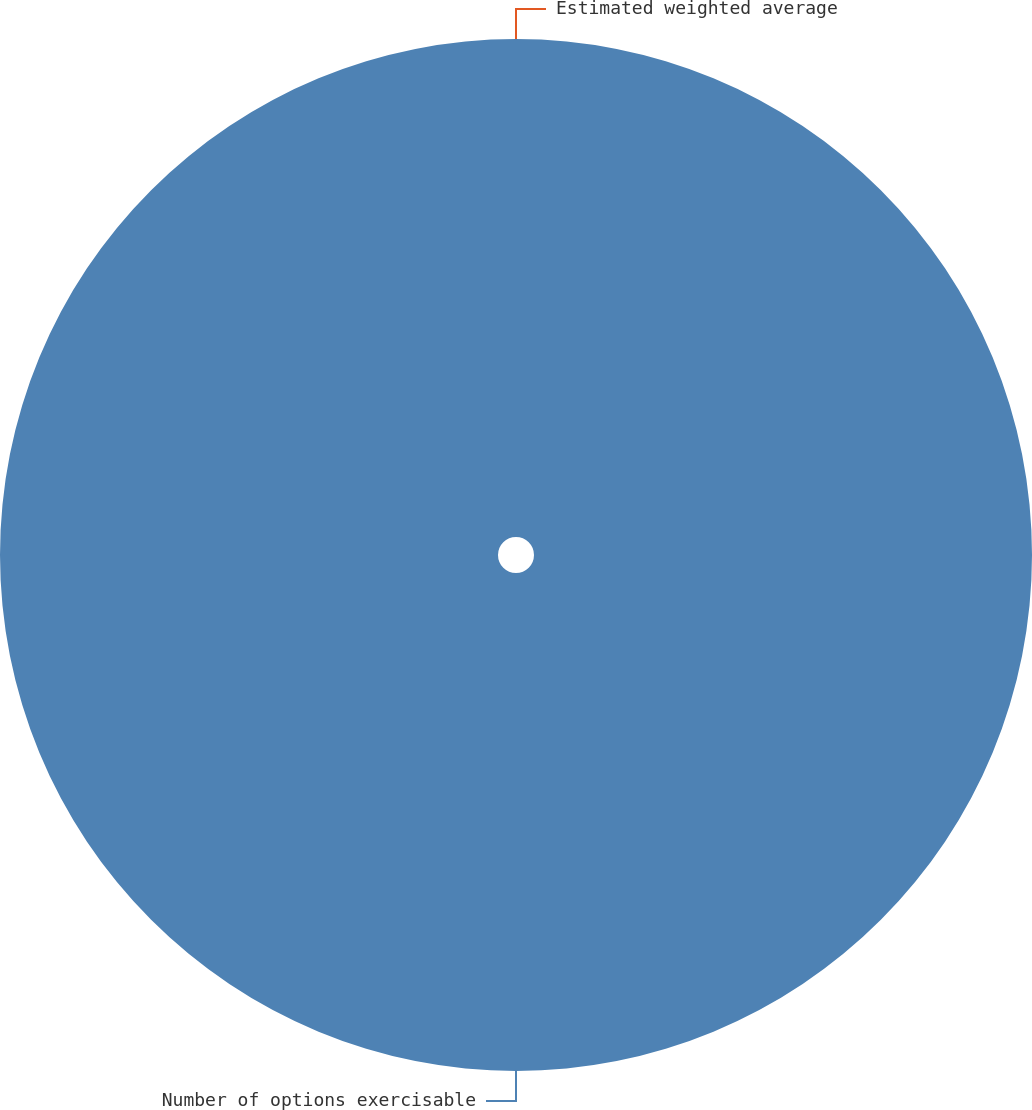<chart> <loc_0><loc_0><loc_500><loc_500><pie_chart><fcel>Number of options exercisable<fcel>Estimated weighted average<nl><fcel>100.0%<fcel>0.0%<nl></chart> 